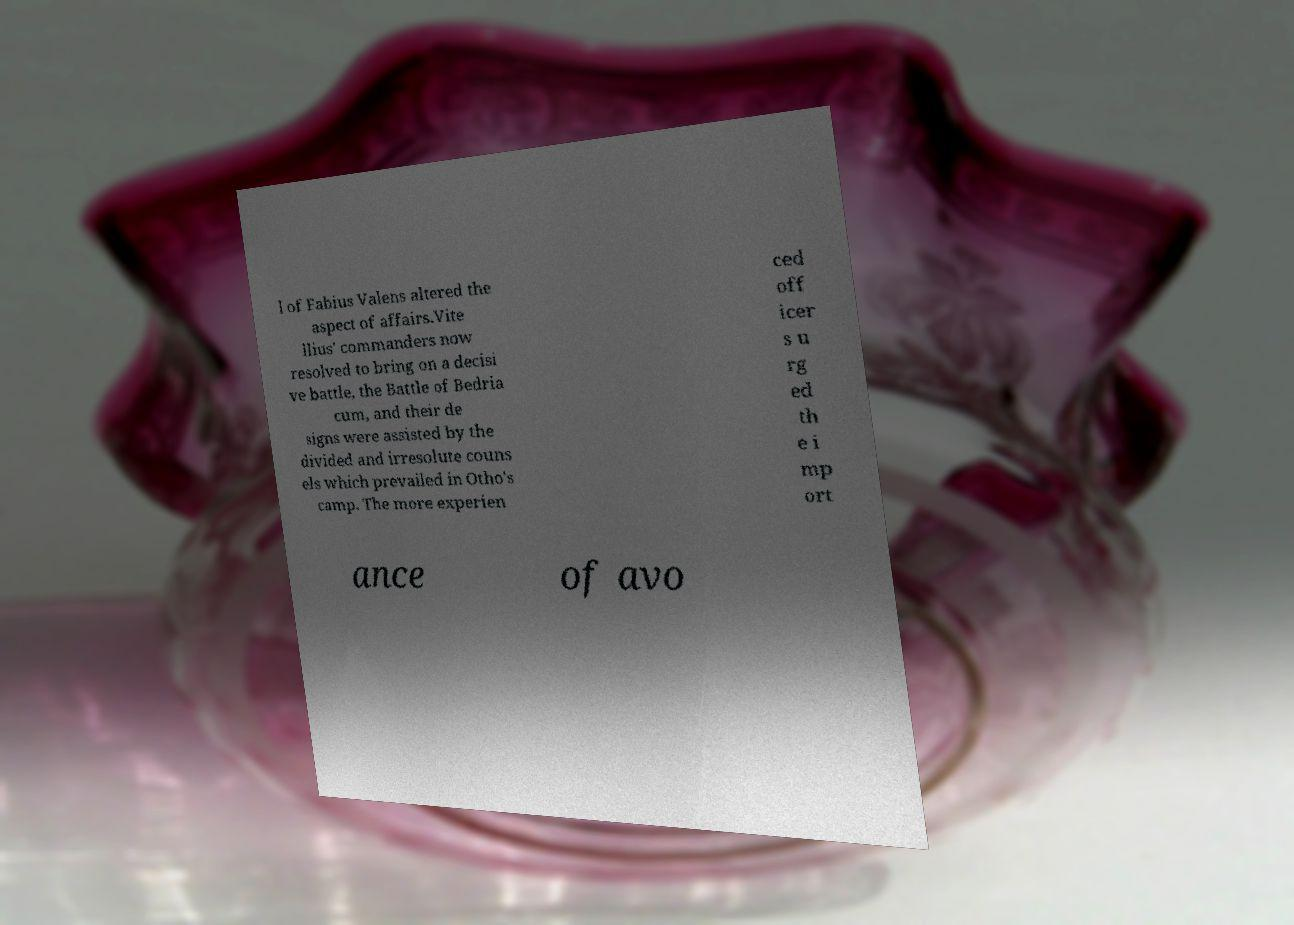Can you read and provide the text displayed in the image?This photo seems to have some interesting text. Can you extract and type it out for me? l of Fabius Valens altered the aspect of affairs.Vite llius' commanders now resolved to bring on a decisi ve battle, the Battle of Bedria cum, and their de signs were assisted by the divided and irresolute couns els which prevailed in Otho's camp. The more experien ced off icer s u rg ed th e i mp ort ance of avo 